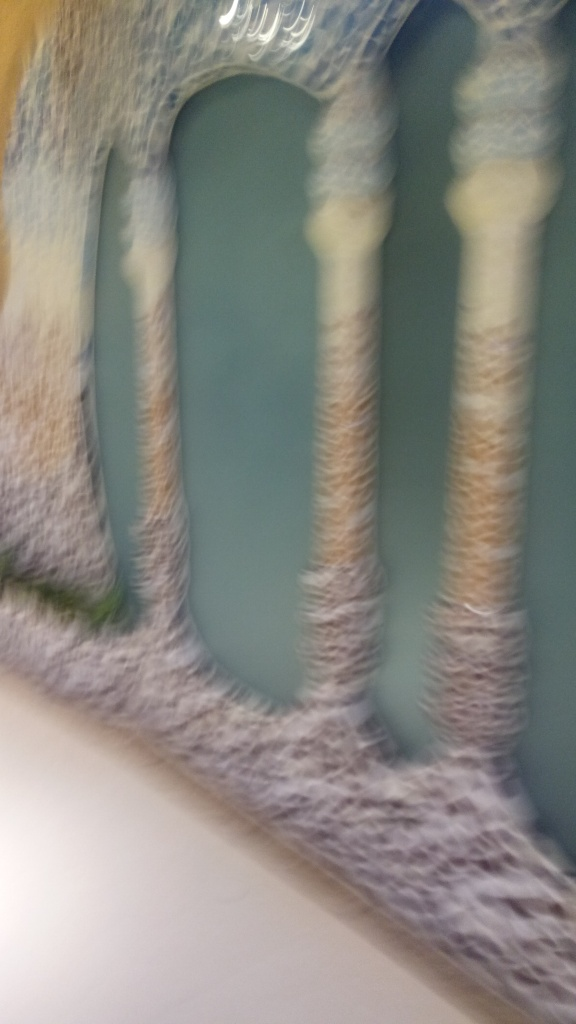Is the image of high quality?
A. No
B. Yes
Answer with the option's letter from the given choices directly.
 A. 